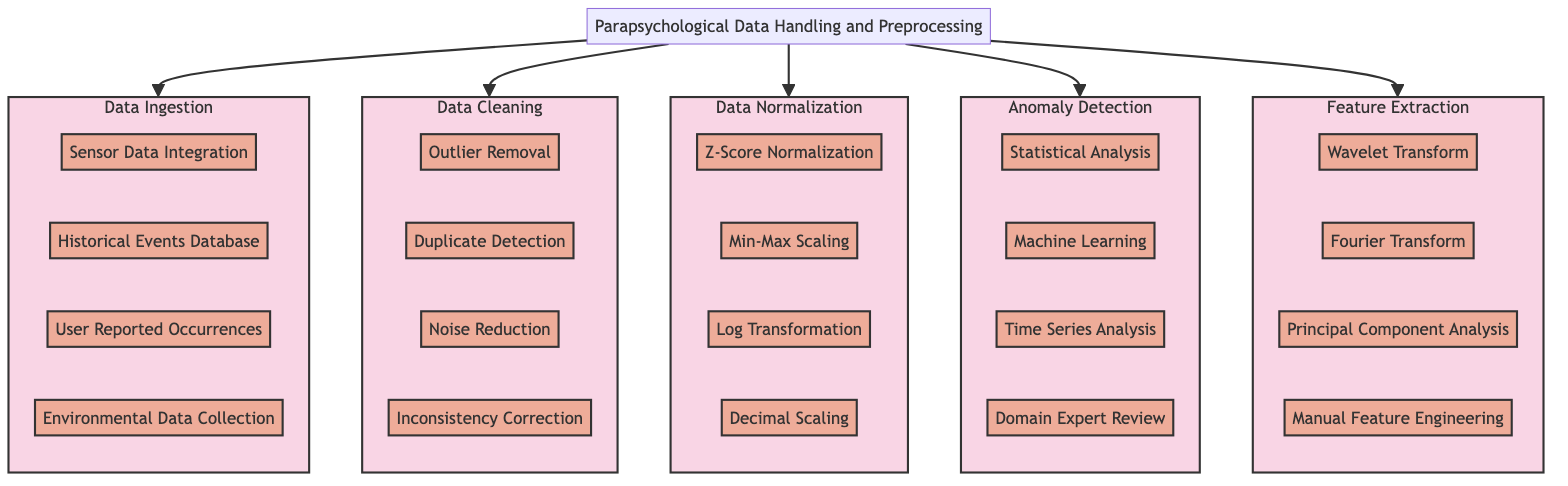What is the first step in the Parapsychological Data Handling and Preprocessing Pathway? The diagram specifies that the first step is "Data Ingestion," as it is the first component branching from the main Parapsychological Data Handling and Preprocessing node.
Answer: Data Ingestion How many components are there in the Data Cleaning section? By examining the Data Cleaning subsection of the diagram, we can count four distinct components listed under it: Outlier Removal, Duplicate Detection, Noise Reduction, and Inconsistency Correction.
Answer: Four What technique is used for noise reduction? Within the Data Cleaning section, there is a specific technique labeled "Noise Reduction," indicating its use in the preprocessing workflow.
Answer: Noise Reduction Which method belongs to the Anomaly Detection phase? There are four methods listed under the Anomaly Detection section, one of which is "Statistical Anomaly Detection," indicating its classification within this phase of the pathway.
Answer: Statistical Anomaly Detection How many techniques are used in the Data Normalization stage? The Data Normalization section of the diagram lists four techniques: Z-Score Normalization, Min-Max Scaling, Log Transformation, and Decimal Scaling, leading to the conclusion about their quantity.
Answer: Four Which component directly follows Data Ingestion? In tracing the flow of the diagram, we observe that after Data Ingestion, the next step is Data Cleaning, making it the immediate following component.
Answer: Data Cleaning What are the approaches used in Feature Extraction? In the Feature Extraction section, we can identify four approaches detailed: Wavelet Transform, Fourier Transform, Principal Component Analysis, and Manual Feature Engineering, outlining the methods employed here.
Answer: Wavelet Transform, Fourier Transform, Principal Component Analysis, Manual Feature Engineering What is the overall purpose of the Parapsychological Data Handling and Preprocessing Pathway? The diagram indicates that the entire sequence process aims at preparing parapsychological data for AI model training, including ingestion, cleaning, normalization, and feature extraction.
Answer: To prepare data for AI model training Which type of data is included in Data Ingestion? The Data Ingestion section specifically lists four data types, including Sensor Data Integration, Historical Events Database, User Reported Occurrences, and Environmental Data Collection, showcasing the breadth of information gathered.
Answer: Sensor Data Integration, Historical Events Database, User Reported Occurrences, Environmental Data Collection 